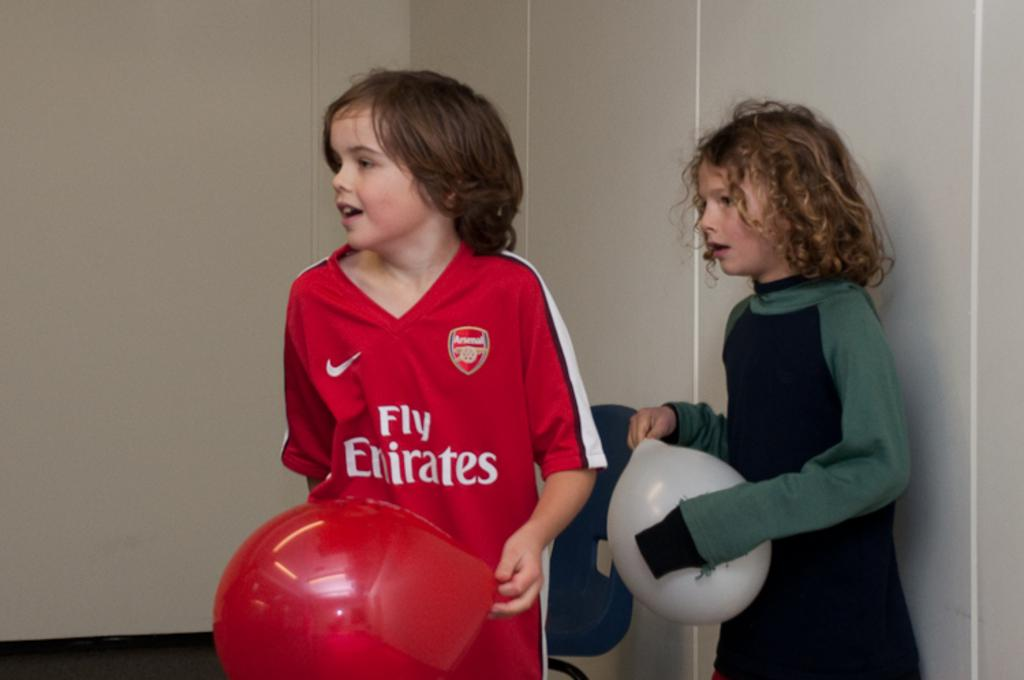<image>
Provide a brief description of the given image. A boy wears a red jersey that is sponsored by Fly Emirates 